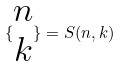<formula> <loc_0><loc_0><loc_500><loc_500>\{ \begin{matrix} n \\ k \end{matrix} \} = S ( n , k )</formula> 